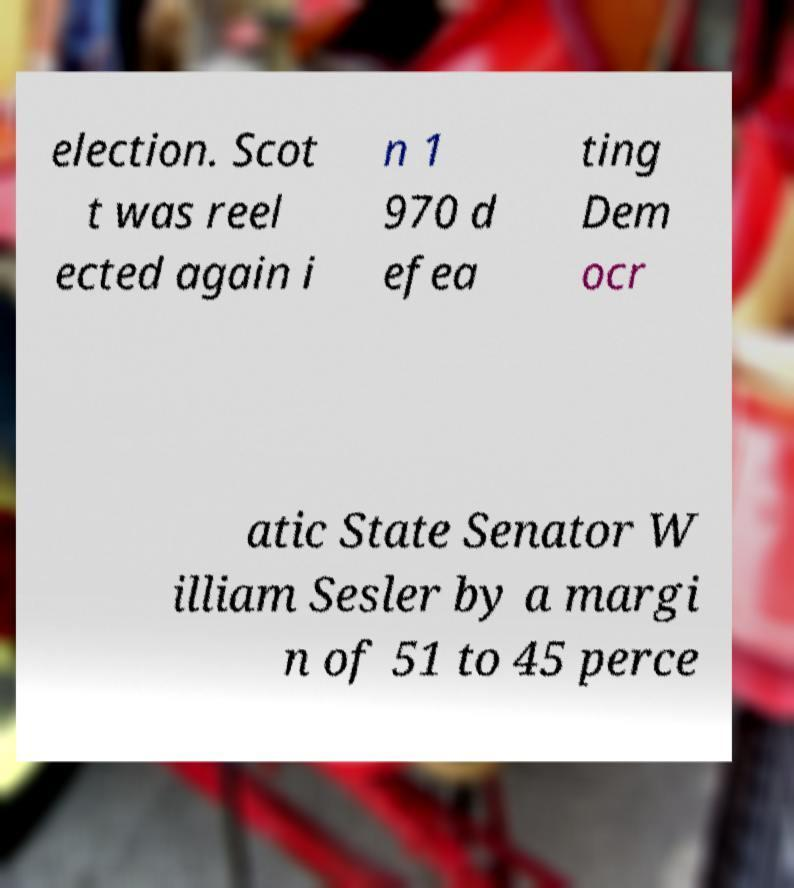Could you extract and type out the text from this image? election. Scot t was reel ected again i n 1 970 d efea ting Dem ocr atic State Senator W illiam Sesler by a margi n of 51 to 45 perce 